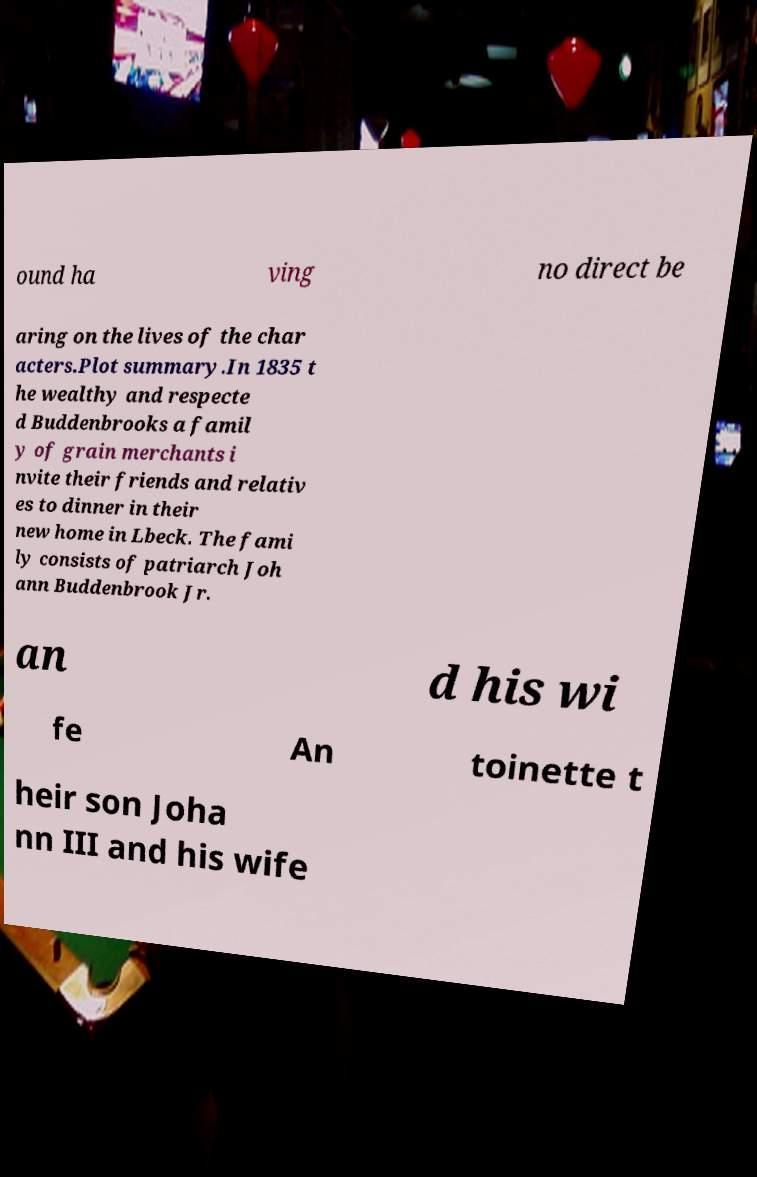Could you assist in decoding the text presented in this image and type it out clearly? ound ha ving no direct be aring on the lives of the char acters.Plot summary.In 1835 t he wealthy and respecte d Buddenbrooks a famil y of grain merchants i nvite their friends and relativ es to dinner in their new home in Lbeck. The fami ly consists of patriarch Joh ann Buddenbrook Jr. an d his wi fe An toinette t heir son Joha nn III and his wife 